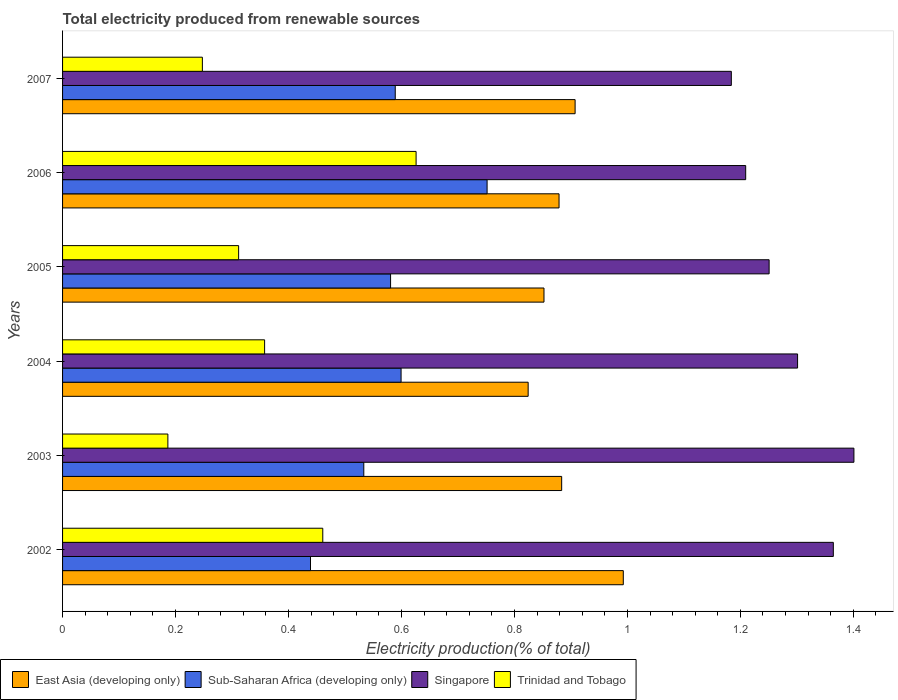How many groups of bars are there?
Your response must be concise. 6. Are the number of bars on each tick of the Y-axis equal?
Your answer should be very brief. Yes. How many bars are there on the 5th tick from the top?
Provide a succinct answer. 4. How many bars are there on the 2nd tick from the bottom?
Your answer should be compact. 4. What is the label of the 5th group of bars from the top?
Ensure brevity in your answer.  2003. What is the total electricity produced in Trinidad and Tobago in 2003?
Provide a succinct answer. 0.19. Across all years, what is the maximum total electricity produced in Trinidad and Tobago?
Your response must be concise. 0.63. Across all years, what is the minimum total electricity produced in East Asia (developing only)?
Ensure brevity in your answer.  0.82. In which year was the total electricity produced in East Asia (developing only) maximum?
Your answer should be very brief. 2002. What is the total total electricity produced in Trinidad and Tobago in the graph?
Offer a terse response. 2.19. What is the difference between the total electricity produced in Trinidad and Tobago in 2002 and that in 2005?
Your response must be concise. 0.15. What is the difference between the total electricity produced in Sub-Saharan Africa (developing only) in 2006 and the total electricity produced in East Asia (developing only) in 2003?
Your answer should be very brief. -0.13. What is the average total electricity produced in Sub-Saharan Africa (developing only) per year?
Offer a terse response. 0.58. In the year 2002, what is the difference between the total electricity produced in Trinidad and Tobago and total electricity produced in Sub-Saharan Africa (developing only)?
Offer a very short reply. 0.02. In how many years, is the total electricity produced in East Asia (developing only) greater than 0.24000000000000002 %?
Make the answer very short. 6. What is the ratio of the total electricity produced in Singapore in 2002 to that in 2004?
Offer a very short reply. 1.05. Is the total electricity produced in Sub-Saharan Africa (developing only) in 2002 less than that in 2007?
Offer a terse response. Yes. Is the difference between the total electricity produced in Trinidad and Tobago in 2003 and 2006 greater than the difference between the total electricity produced in Sub-Saharan Africa (developing only) in 2003 and 2006?
Your response must be concise. No. What is the difference between the highest and the second highest total electricity produced in Sub-Saharan Africa (developing only)?
Make the answer very short. 0.15. What is the difference between the highest and the lowest total electricity produced in Singapore?
Make the answer very short. 0.22. In how many years, is the total electricity produced in Sub-Saharan Africa (developing only) greater than the average total electricity produced in Sub-Saharan Africa (developing only) taken over all years?
Offer a terse response. 3. Is the sum of the total electricity produced in Singapore in 2002 and 2005 greater than the maximum total electricity produced in East Asia (developing only) across all years?
Ensure brevity in your answer.  Yes. Is it the case that in every year, the sum of the total electricity produced in Singapore and total electricity produced in Trinidad and Tobago is greater than the sum of total electricity produced in East Asia (developing only) and total electricity produced in Sub-Saharan Africa (developing only)?
Your answer should be compact. Yes. What does the 4th bar from the top in 2004 represents?
Give a very brief answer. East Asia (developing only). What does the 3rd bar from the bottom in 2003 represents?
Provide a succinct answer. Singapore. Are the values on the major ticks of X-axis written in scientific E-notation?
Give a very brief answer. No. Where does the legend appear in the graph?
Offer a very short reply. Bottom left. What is the title of the graph?
Your answer should be compact. Total electricity produced from renewable sources. What is the label or title of the X-axis?
Your answer should be very brief. Electricity production(% of total). What is the label or title of the Y-axis?
Provide a succinct answer. Years. What is the Electricity production(% of total) of East Asia (developing only) in 2002?
Give a very brief answer. 0.99. What is the Electricity production(% of total) in Sub-Saharan Africa (developing only) in 2002?
Offer a very short reply. 0.44. What is the Electricity production(% of total) in Singapore in 2002?
Offer a very short reply. 1.36. What is the Electricity production(% of total) of Trinidad and Tobago in 2002?
Your answer should be compact. 0.46. What is the Electricity production(% of total) of East Asia (developing only) in 2003?
Ensure brevity in your answer.  0.88. What is the Electricity production(% of total) in Sub-Saharan Africa (developing only) in 2003?
Offer a terse response. 0.53. What is the Electricity production(% of total) of Singapore in 2003?
Your answer should be very brief. 1.4. What is the Electricity production(% of total) in Trinidad and Tobago in 2003?
Offer a terse response. 0.19. What is the Electricity production(% of total) in East Asia (developing only) in 2004?
Your response must be concise. 0.82. What is the Electricity production(% of total) in Sub-Saharan Africa (developing only) in 2004?
Your answer should be compact. 0.6. What is the Electricity production(% of total) in Singapore in 2004?
Keep it short and to the point. 1.3. What is the Electricity production(% of total) of Trinidad and Tobago in 2004?
Your answer should be compact. 0.36. What is the Electricity production(% of total) in East Asia (developing only) in 2005?
Provide a short and direct response. 0.85. What is the Electricity production(% of total) in Sub-Saharan Africa (developing only) in 2005?
Keep it short and to the point. 0.58. What is the Electricity production(% of total) of Singapore in 2005?
Ensure brevity in your answer.  1.25. What is the Electricity production(% of total) of Trinidad and Tobago in 2005?
Provide a succinct answer. 0.31. What is the Electricity production(% of total) of East Asia (developing only) in 2006?
Your response must be concise. 0.88. What is the Electricity production(% of total) of Sub-Saharan Africa (developing only) in 2006?
Your answer should be compact. 0.75. What is the Electricity production(% of total) in Singapore in 2006?
Offer a terse response. 1.21. What is the Electricity production(% of total) of Trinidad and Tobago in 2006?
Offer a terse response. 0.63. What is the Electricity production(% of total) in East Asia (developing only) in 2007?
Give a very brief answer. 0.91. What is the Electricity production(% of total) in Sub-Saharan Africa (developing only) in 2007?
Your answer should be very brief. 0.59. What is the Electricity production(% of total) of Singapore in 2007?
Ensure brevity in your answer.  1.18. What is the Electricity production(% of total) of Trinidad and Tobago in 2007?
Your answer should be compact. 0.25. Across all years, what is the maximum Electricity production(% of total) in East Asia (developing only)?
Keep it short and to the point. 0.99. Across all years, what is the maximum Electricity production(% of total) of Sub-Saharan Africa (developing only)?
Give a very brief answer. 0.75. Across all years, what is the maximum Electricity production(% of total) of Singapore?
Provide a short and direct response. 1.4. Across all years, what is the maximum Electricity production(% of total) of Trinidad and Tobago?
Ensure brevity in your answer.  0.63. Across all years, what is the minimum Electricity production(% of total) in East Asia (developing only)?
Provide a succinct answer. 0.82. Across all years, what is the minimum Electricity production(% of total) of Sub-Saharan Africa (developing only)?
Offer a very short reply. 0.44. Across all years, what is the minimum Electricity production(% of total) in Singapore?
Provide a short and direct response. 1.18. Across all years, what is the minimum Electricity production(% of total) in Trinidad and Tobago?
Your response must be concise. 0.19. What is the total Electricity production(% of total) in East Asia (developing only) in the graph?
Provide a short and direct response. 5.34. What is the total Electricity production(% of total) of Sub-Saharan Africa (developing only) in the graph?
Provide a short and direct response. 3.49. What is the total Electricity production(% of total) of Singapore in the graph?
Your response must be concise. 7.71. What is the total Electricity production(% of total) in Trinidad and Tobago in the graph?
Offer a terse response. 2.19. What is the difference between the Electricity production(% of total) in East Asia (developing only) in 2002 and that in 2003?
Keep it short and to the point. 0.11. What is the difference between the Electricity production(% of total) in Sub-Saharan Africa (developing only) in 2002 and that in 2003?
Your answer should be compact. -0.09. What is the difference between the Electricity production(% of total) of Singapore in 2002 and that in 2003?
Ensure brevity in your answer.  -0.04. What is the difference between the Electricity production(% of total) in Trinidad and Tobago in 2002 and that in 2003?
Offer a very short reply. 0.27. What is the difference between the Electricity production(% of total) in East Asia (developing only) in 2002 and that in 2004?
Ensure brevity in your answer.  0.17. What is the difference between the Electricity production(% of total) of Sub-Saharan Africa (developing only) in 2002 and that in 2004?
Your answer should be very brief. -0.16. What is the difference between the Electricity production(% of total) in Singapore in 2002 and that in 2004?
Your response must be concise. 0.06. What is the difference between the Electricity production(% of total) of Trinidad and Tobago in 2002 and that in 2004?
Your response must be concise. 0.1. What is the difference between the Electricity production(% of total) in East Asia (developing only) in 2002 and that in 2005?
Offer a very short reply. 0.14. What is the difference between the Electricity production(% of total) in Sub-Saharan Africa (developing only) in 2002 and that in 2005?
Your answer should be very brief. -0.14. What is the difference between the Electricity production(% of total) in Singapore in 2002 and that in 2005?
Provide a short and direct response. 0.11. What is the difference between the Electricity production(% of total) of Trinidad and Tobago in 2002 and that in 2005?
Offer a very short reply. 0.15. What is the difference between the Electricity production(% of total) of East Asia (developing only) in 2002 and that in 2006?
Give a very brief answer. 0.11. What is the difference between the Electricity production(% of total) in Sub-Saharan Africa (developing only) in 2002 and that in 2006?
Provide a succinct answer. -0.31. What is the difference between the Electricity production(% of total) of Singapore in 2002 and that in 2006?
Make the answer very short. 0.16. What is the difference between the Electricity production(% of total) in Trinidad and Tobago in 2002 and that in 2006?
Your answer should be compact. -0.17. What is the difference between the Electricity production(% of total) of East Asia (developing only) in 2002 and that in 2007?
Your answer should be very brief. 0.09. What is the difference between the Electricity production(% of total) in Singapore in 2002 and that in 2007?
Provide a short and direct response. 0.18. What is the difference between the Electricity production(% of total) in Trinidad and Tobago in 2002 and that in 2007?
Provide a succinct answer. 0.21. What is the difference between the Electricity production(% of total) of East Asia (developing only) in 2003 and that in 2004?
Ensure brevity in your answer.  0.06. What is the difference between the Electricity production(% of total) in Sub-Saharan Africa (developing only) in 2003 and that in 2004?
Offer a very short reply. -0.07. What is the difference between the Electricity production(% of total) in Singapore in 2003 and that in 2004?
Make the answer very short. 0.1. What is the difference between the Electricity production(% of total) in Trinidad and Tobago in 2003 and that in 2004?
Your answer should be very brief. -0.17. What is the difference between the Electricity production(% of total) of East Asia (developing only) in 2003 and that in 2005?
Your answer should be compact. 0.03. What is the difference between the Electricity production(% of total) in Sub-Saharan Africa (developing only) in 2003 and that in 2005?
Your response must be concise. -0.05. What is the difference between the Electricity production(% of total) of Singapore in 2003 and that in 2005?
Offer a very short reply. 0.15. What is the difference between the Electricity production(% of total) in Trinidad and Tobago in 2003 and that in 2005?
Make the answer very short. -0.13. What is the difference between the Electricity production(% of total) of East Asia (developing only) in 2003 and that in 2006?
Your answer should be compact. 0. What is the difference between the Electricity production(% of total) in Sub-Saharan Africa (developing only) in 2003 and that in 2006?
Provide a succinct answer. -0.22. What is the difference between the Electricity production(% of total) in Singapore in 2003 and that in 2006?
Offer a very short reply. 0.19. What is the difference between the Electricity production(% of total) in Trinidad and Tobago in 2003 and that in 2006?
Keep it short and to the point. -0.44. What is the difference between the Electricity production(% of total) of East Asia (developing only) in 2003 and that in 2007?
Your answer should be compact. -0.02. What is the difference between the Electricity production(% of total) in Sub-Saharan Africa (developing only) in 2003 and that in 2007?
Give a very brief answer. -0.06. What is the difference between the Electricity production(% of total) of Singapore in 2003 and that in 2007?
Provide a succinct answer. 0.22. What is the difference between the Electricity production(% of total) in Trinidad and Tobago in 2003 and that in 2007?
Your answer should be very brief. -0.06. What is the difference between the Electricity production(% of total) in East Asia (developing only) in 2004 and that in 2005?
Offer a very short reply. -0.03. What is the difference between the Electricity production(% of total) of Sub-Saharan Africa (developing only) in 2004 and that in 2005?
Make the answer very short. 0.02. What is the difference between the Electricity production(% of total) of Singapore in 2004 and that in 2005?
Your response must be concise. 0.05. What is the difference between the Electricity production(% of total) in Trinidad and Tobago in 2004 and that in 2005?
Make the answer very short. 0.05. What is the difference between the Electricity production(% of total) in East Asia (developing only) in 2004 and that in 2006?
Provide a short and direct response. -0.05. What is the difference between the Electricity production(% of total) of Sub-Saharan Africa (developing only) in 2004 and that in 2006?
Ensure brevity in your answer.  -0.15. What is the difference between the Electricity production(% of total) in Singapore in 2004 and that in 2006?
Give a very brief answer. 0.09. What is the difference between the Electricity production(% of total) in Trinidad and Tobago in 2004 and that in 2006?
Provide a succinct answer. -0.27. What is the difference between the Electricity production(% of total) of East Asia (developing only) in 2004 and that in 2007?
Your answer should be compact. -0.08. What is the difference between the Electricity production(% of total) in Sub-Saharan Africa (developing only) in 2004 and that in 2007?
Offer a terse response. 0.01. What is the difference between the Electricity production(% of total) of Singapore in 2004 and that in 2007?
Give a very brief answer. 0.12. What is the difference between the Electricity production(% of total) of Trinidad and Tobago in 2004 and that in 2007?
Make the answer very short. 0.11. What is the difference between the Electricity production(% of total) of East Asia (developing only) in 2005 and that in 2006?
Ensure brevity in your answer.  -0.03. What is the difference between the Electricity production(% of total) in Sub-Saharan Africa (developing only) in 2005 and that in 2006?
Your response must be concise. -0.17. What is the difference between the Electricity production(% of total) in Singapore in 2005 and that in 2006?
Your answer should be compact. 0.04. What is the difference between the Electricity production(% of total) in Trinidad and Tobago in 2005 and that in 2006?
Offer a very short reply. -0.31. What is the difference between the Electricity production(% of total) of East Asia (developing only) in 2005 and that in 2007?
Offer a terse response. -0.06. What is the difference between the Electricity production(% of total) in Sub-Saharan Africa (developing only) in 2005 and that in 2007?
Keep it short and to the point. -0.01. What is the difference between the Electricity production(% of total) of Singapore in 2005 and that in 2007?
Offer a terse response. 0.07. What is the difference between the Electricity production(% of total) in Trinidad and Tobago in 2005 and that in 2007?
Offer a terse response. 0.06. What is the difference between the Electricity production(% of total) of East Asia (developing only) in 2006 and that in 2007?
Your answer should be compact. -0.03. What is the difference between the Electricity production(% of total) in Sub-Saharan Africa (developing only) in 2006 and that in 2007?
Ensure brevity in your answer.  0.16. What is the difference between the Electricity production(% of total) of Singapore in 2006 and that in 2007?
Ensure brevity in your answer.  0.03. What is the difference between the Electricity production(% of total) of Trinidad and Tobago in 2006 and that in 2007?
Provide a succinct answer. 0.38. What is the difference between the Electricity production(% of total) in East Asia (developing only) in 2002 and the Electricity production(% of total) in Sub-Saharan Africa (developing only) in 2003?
Ensure brevity in your answer.  0.46. What is the difference between the Electricity production(% of total) in East Asia (developing only) in 2002 and the Electricity production(% of total) in Singapore in 2003?
Your answer should be compact. -0.41. What is the difference between the Electricity production(% of total) of East Asia (developing only) in 2002 and the Electricity production(% of total) of Trinidad and Tobago in 2003?
Ensure brevity in your answer.  0.81. What is the difference between the Electricity production(% of total) of Sub-Saharan Africa (developing only) in 2002 and the Electricity production(% of total) of Singapore in 2003?
Your answer should be compact. -0.96. What is the difference between the Electricity production(% of total) in Sub-Saharan Africa (developing only) in 2002 and the Electricity production(% of total) in Trinidad and Tobago in 2003?
Your response must be concise. 0.25. What is the difference between the Electricity production(% of total) in Singapore in 2002 and the Electricity production(% of total) in Trinidad and Tobago in 2003?
Make the answer very short. 1.18. What is the difference between the Electricity production(% of total) in East Asia (developing only) in 2002 and the Electricity production(% of total) in Sub-Saharan Africa (developing only) in 2004?
Your answer should be compact. 0.39. What is the difference between the Electricity production(% of total) in East Asia (developing only) in 2002 and the Electricity production(% of total) in Singapore in 2004?
Provide a short and direct response. -0.31. What is the difference between the Electricity production(% of total) of East Asia (developing only) in 2002 and the Electricity production(% of total) of Trinidad and Tobago in 2004?
Keep it short and to the point. 0.64. What is the difference between the Electricity production(% of total) of Sub-Saharan Africa (developing only) in 2002 and the Electricity production(% of total) of Singapore in 2004?
Make the answer very short. -0.86. What is the difference between the Electricity production(% of total) of Sub-Saharan Africa (developing only) in 2002 and the Electricity production(% of total) of Trinidad and Tobago in 2004?
Offer a very short reply. 0.08. What is the difference between the Electricity production(% of total) in Singapore in 2002 and the Electricity production(% of total) in Trinidad and Tobago in 2004?
Make the answer very short. 1.01. What is the difference between the Electricity production(% of total) of East Asia (developing only) in 2002 and the Electricity production(% of total) of Sub-Saharan Africa (developing only) in 2005?
Give a very brief answer. 0.41. What is the difference between the Electricity production(% of total) of East Asia (developing only) in 2002 and the Electricity production(% of total) of Singapore in 2005?
Provide a short and direct response. -0.26. What is the difference between the Electricity production(% of total) in East Asia (developing only) in 2002 and the Electricity production(% of total) in Trinidad and Tobago in 2005?
Your response must be concise. 0.68. What is the difference between the Electricity production(% of total) in Sub-Saharan Africa (developing only) in 2002 and the Electricity production(% of total) in Singapore in 2005?
Ensure brevity in your answer.  -0.81. What is the difference between the Electricity production(% of total) of Sub-Saharan Africa (developing only) in 2002 and the Electricity production(% of total) of Trinidad and Tobago in 2005?
Your response must be concise. 0.13. What is the difference between the Electricity production(% of total) of Singapore in 2002 and the Electricity production(% of total) of Trinidad and Tobago in 2005?
Your answer should be compact. 1.05. What is the difference between the Electricity production(% of total) in East Asia (developing only) in 2002 and the Electricity production(% of total) in Sub-Saharan Africa (developing only) in 2006?
Provide a succinct answer. 0.24. What is the difference between the Electricity production(% of total) of East Asia (developing only) in 2002 and the Electricity production(% of total) of Singapore in 2006?
Keep it short and to the point. -0.22. What is the difference between the Electricity production(% of total) in East Asia (developing only) in 2002 and the Electricity production(% of total) in Trinidad and Tobago in 2006?
Keep it short and to the point. 0.37. What is the difference between the Electricity production(% of total) in Sub-Saharan Africa (developing only) in 2002 and the Electricity production(% of total) in Singapore in 2006?
Provide a succinct answer. -0.77. What is the difference between the Electricity production(% of total) of Sub-Saharan Africa (developing only) in 2002 and the Electricity production(% of total) of Trinidad and Tobago in 2006?
Keep it short and to the point. -0.19. What is the difference between the Electricity production(% of total) of Singapore in 2002 and the Electricity production(% of total) of Trinidad and Tobago in 2006?
Your response must be concise. 0.74. What is the difference between the Electricity production(% of total) in East Asia (developing only) in 2002 and the Electricity production(% of total) in Sub-Saharan Africa (developing only) in 2007?
Your answer should be compact. 0.4. What is the difference between the Electricity production(% of total) in East Asia (developing only) in 2002 and the Electricity production(% of total) in Singapore in 2007?
Keep it short and to the point. -0.19. What is the difference between the Electricity production(% of total) of East Asia (developing only) in 2002 and the Electricity production(% of total) of Trinidad and Tobago in 2007?
Give a very brief answer. 0.75. What is the difference between the Electricity production(% of total) in Sub-Saharan Africa (developing only) in 2002 and the Electricity production(% of total) in Singapore in 2007?
Offer a very short reply. -0.74. What is the difference between the Electricity production(% of total) in Sub-Saharan Africa (developing only) in 2002 and the Electricity production(% of total) in Trinidad and Tobago in 2007?
Keep it short and to the point. 0.19. What is the difference between the Electricity production(% of total) of Singapore in 2002 and the Electricity production(% of total) of Trinidad and Tobago in 2007?
Give a very brief answer. 1.12. What is the difference between the Electricity production(% of total) in East Asia (developing only) in 2003 and the Electricity production(% of total) in Sub-Saharan Africa (developing only) in 2004?
Offer a terse response. 0.28. What is the difference between the Electricity production(% of total) of East Asia (developing only) in 2003 and the Electricity production(% of total) of Singapore in 2004?
Ensure brevity in your answer.  -0.42. What is the difference between the Electricity production(% of total) of East Asia (developing only) in 2003 and the Electricity production(% of total) of Trinidad and Tobago in 2004?
Your response must be concise. 0.53. What is the difference between the Electricity production(% of total) in Sub-Saharan Africa (developing only) in 2003 and the Electricity production(% of total) in Singapore in 2004?
Ensure brevity in your answer.  -0.77. What is the difference between the Electricity production(% of total) of Sub-Saharan Africa (developing only) in 2003 and the Electricity production(% of total) of Trinidad and Tobago in 2004?
Offer a terse response. 0.18. What is the difference between the Electricity production(% of total) in Singapore in 2003 and the Electricity production(% of total) in Trinidad and Tobago in 2004?
Your answer should be compact. 1.04. What is the difference between the Electricity production(% of total) in East Asia (developing only) in 2003 and the Electricity production(% of total) in Sub-Saharan Africa (developing only) in 2005?
Make the answer very short. 0.3. What is the difference between the Electricity production(% of total) in East Asia (developing only) in 2003 and the Electricity production(% of total) in Singapore in 2005?
Ensure brevity in your answer.  -0.37. What is the difference between the Electricity production(% of total) of East Asia (developing only) in 2003 and the Electricity production(% of total) of Trinidad and Tobago in 2005?
Offer a very short reply. 0.57. What is the difference between the Electricity production(% of total) in Sub-Saharan Africa (developing only) in 2003 and the Electricity production(% of total) in Singapore in 2005?
Your answer should be very brief. -0.72. What is the difference between the Electricity production(% of total) of Sub-Saharan Africa (developing only) in 2003 and the Electricity production(% of total) of Trinidad and Tobago in 2005?
Make the answer very short. 0.22. What is the difference between the Electricity production(% of total) in Singapore in 2003 and the Electricity production(% of total) in Trinidad and Tobago in 2005?
Keep it short and to the point. 1.09. What is the difference between the Electricity production(% of total) in East Asia (developing only) in 2003 and the Electricity production(% of total) in Sub-Saharan Africa (developing only) in 2006?
Make the answer very short. 0.13. What is the difference between the Electricity production(% of total) in East Asia (developing only) in 2003 and the Electricity production(% of total) in Singapore in 2006?
Your response must be concise. -0.33. What is the difference between the Electricity production(% of total) of East Asia (developing only) in 2003 and the Electricity production(% of total) of Trinidad and Tobago in 2006?
Make the answer very short. 0.26. What is the difference between the Electricity production(% of total) in Sub-Saharan Africa (developing only) in 2003 and the Electricity production(% of total) in Singapore in 2006?
Give a very brief answer. -0.68. What is the difference between the Electricity production(% of total) of Sub-Saharan Africa (developing only) in 2003 and the Electricity production(% of total) of Trinidad and Tobago in 2006?
Keep it short and to the point. -0.09. What is the difference between the Electricity production(% of total) in Singapore in 2003 and the Electricity production(% of total) in Trinidad and Tobago in 2006?
Keep it short and to the point. 0.78. What is the difference between the Electricity production(% of total) of East Asia (developing only) in 2003 and the Electricity production(% of total) of Sub-Saharan Africa (developing only) in 2007?
Offer a terse response. 0.29. What is the difference between the Electricity production(% of total) in East Asia (developing only) in 2003 and the Electricity production(% of total) in Singapore in 2007?
Keep it short and to the point. -0.3. What is the difference between the Electricity production(% of total) in East Asia (developing only) in 2003 and the Electricity production(% of total) in Trinidad and Tobago in 2007?
Provide a succinct answer. 0.64. What is the difference between the Electricity production(% of total) of Sub-Saharan Africa (developing only) in 2003 and the Electricity production(% of total) of Singapore in 2007?
Your response must be concise. -0.65. What is the difference between the Electricity production(% of total) in Sub-Saharan Africa (developing only) in 2003 and the Electricity production(% of total) in Trinidad and Tobago in 2007?
Offer a very short reply. 0.29. What is the difference between the Electricity production(% of total) of Singapore in 2003 and the Electricity production(% of total) of Trinidad and Tobago in 2007?
Your answer should be very brief. 1.15. What is the difference between the Electricity production(% of total) of East Asia (developing only) in 2004 and the Electricity production(% of total) of Sub-Saharan Africa (developing only) in 2005?
Make the answer very short. 0.24. What is the difference between the Electricity production(% of total) of East Asia (developing only) in 2004 and the Electricity production(% of total) of Singapore in 2005?
Your answer should be compact. -0.43. What is the difference between the Electricity production(% of total) of East Asia (developing only) in 2004 and the Electricity production(% of total) of Trinidad and Tobago in 2005?
Keep it short and to the point. 0.51. What is the difference between the Electricity production(% of total) of Sub-Saharan Africa (developing only) in 2004 and the Electricity production(% of total) of Singapore in 2005?
Provide a succinct answer. -0.65. What is the difference between the Electricity production(% of total) in Sub-Saharan Africa (developing only) in 2004 and the Electricity production(% of total) in Trinidad and Tobago in 2005?
Your answer should be compact. 0.29. What is the difference between the Electricity production(% of total) of Singapore in 2004 and the Electricity production(% of total) of Trinidad and Tobago in 2005?
Provide a succinct answer. 0.99. What is the difference between the Electricity production(% of total) of East Asia (developing only) in 2004 and the Electricity production(% of total) of Sub-Saharan Africa (developing only) in 2006?
Give a very brief answer. 0.07. What is the difference between the Electricity production(% of total) of East Asia (developing only) in 2004 and the Electricity production(% of total) of Singapore in 2006?
Give a very brief answer. -0.39. What is the difference between the Electricity production(% of total) in East Asia (developing only) in 2004 and the Electricity production(% of total) in Trinidad and Tobago in 2006?
Your answer should be very brief. 0.2. What is the difference between the Electricity production(% of total) in Sub-Saharan Africa (developing only) in 2004 and the Electricity production(% of total) in Singapore in 2006?
Offer a terse response. -0.61. What is the difference between the Electricity production(% of total) in Sub-Saharan Africa (developing only) in 2004 and the Electricity production(% of total) in Trinidad and Tobago in 2006?
Your response must be concise. -0.03. What is the difference between the Electricity production(% of total) of Singapore in 2004 and the Electricity production(% of total) of Trinidad and Tobago in 2006?
Provide a succinct answer. 0.68. What is the difference between the Electricity production(% of total) of East Asia (developing only) in 2004 and the Electricity production(% of total) of Sub-Saharan Africa (developing only) in 2007?
Offer a terse response. 0.24. What is the difference between the Electricity production(% of total) of East Asia (developing only) in 2004 and the Electricity production(% of total) of Singapore in 2007?
Keep it short and to the point. -0.36. What is the difference between the Electricity production(% of total) of East Asia (developing only) in 2004 and the Electricity production(% of total) of Trinidad and Tobago in 2007?
Your answer should be very brief. 0.58. What is the difference between the Electricity production(% of total) of Sub-Saharan Africa (developing only) in 2004 and the Electricity production(% of total) of Singapore in 2007?
Keep it short and to the point. -0.58. What is the difference between the Electricity production(% of total) in Sub-Saharan Africa (developing only) in 2004 and the Electricity production(% of total) in Trinidad and Tobago in 2007?
Keep it short and to the point. 0.35. What is the difference between the Electricity production(% of total) of Singapore in 2004 and the Electricity production(% of total) of Trinidad and Tobago in 2007?
Your answer should be compact. 1.05. What is the difference between the Electricity production(% of total) of East Asia (developing only) in 2005 and the Electricity production(% of total) of Sub-Saharan Africa (developing only) in 2006?
Offer a terse response. 0.1. What is the difference between the Electricity production(% of total) of East Asia (developing only) in 2005 and the Electricity production(% of total) of Singapore in 2006?
Your answer should be very brief. -0.36. What is the difference between the Electricity production(% of total) in East Asia (developing only) in 2005 and the Electricity production(% of total) in Trinidad and Tobago in 2006?
Provide a short and direct response. 0.23. What is the difference between the Electricity production(% of total) of Sub-Saharan Africa (developing only) in 2005 and the Electricity production(% of total) of Singapore in 2006?
Keep it short and to the point. -0.63. What is the difference between the Electricity production(% of total) of Sub-Saharan Africa (developing only) in 2005 and the Electricity production(% of total) of Trinidad and Tobago in 2006?
Your response must be concise. -0.05. What is the difference between the Electricity production(% of total) of Singapore in 2005 and the Electricity production(% of total) of Trinidad and Tobago in 2006?
Provide a short and direct response. 0.62. What is the difference between the Electricity production(% of total) in East Asia (developing only) in 2005 and the Electricity production(% of total) in Sub-Saharan Africa (developing only) in 2007?
Make the answer very short. 0.26. What is the difference between the Electricity production(% of total) in East Asia (developing only) in 2005 and the Electricity production(% of total) in Singapore in 2007?
Your response must be concise. -0.33. What is the difference between the Electricity production(% of total) of East Asia (developing only) in 2005 and the Electricity production(% of total) of Trinidad and Tobago in 2007?
Offer a very short reply. 0.6. What is the difference between the Electricity production(% of total) of Sub-Saharan Africa (developing only) in 2005 and the Electricity production(% of total) of Singapore in 2007?
Provide a short and direct response. -0.6. What is the difference between the Electricity production(% of total) of Sub-Saharan Africa (developing only) in 2005 and the Electricity production(% of total) of Trinidad and Tobago in 2007?
Give a very brief answer. 0.33. What is the difference between the Electricity production(% of total) in East Asia (developing only) in 2006 and the Electricity production(% of total) in Sub-Saharan Africa (developing only) in 2007?
Provide a succinct answer. 0.29. What is the difference between the Electricity production(% of total) of East Asia (developing only) in 2006 and the Electricity production(% of total) of Singapore in 2007?
Keep it short and to the point. -0.3. What is the difference between the Electricity production(% of total) of East Asia (developing only) in 2006 and the Electricity production(% of total) of Trinidad and Tobago in 2007?
Your response must be concise. 0.63. What is the difference between the Electricity production(% of total) in Sub-Saharan Africa (developing only) in 2006 and the Electricity production(% of total) in Singapore in 2007?
Offer a terse response. -0.43. What is the difference between the Electricity production(% of total) in Sub-Saharan Africa (developing only) in 2006 and the Electricity production(% of total) in Trinidad and Tobago in 2007?
Make the answer very short. 0.5. What is the difference between the Electricity production(% of total) in Singapore in 2006 and the Electricity production(% of total) in Trinidad and Tobago in 2007?
Keep it short and to the point. 0.96. What is the average Electricity production(% of total) of East Asia (developing only) per year?
Provide a short and direct response. 0.89. What is the average Electricity production(% of total) of Sub-Saharan Africa (developing only) per year?
Provide a short and direct response. 0.58. What is the average Electricity production(% of total) in Singapore per year?
Keep it short and to the point. 1.29. What is the average Electricity production(% of total) in Trinidad and Tobago per year?
Make the answer very short. 0.36. In the year 2002, what is the difference between the Electricity production(% of total) of East Asia (developing only) and Electricity production(% of total) of Sub-Saharan Africa (developing only)?
Ensure brevity in your answer.  0.55. In the year 2002, what is the difference between the Electricity production(% of total) of East Asia (developing only) and Electricity production(% of total) of Singapore?
Keep it short and to the point. -0.37. In the year 2002, what is the difference between the Electricity production(% of total) in East Asia (developing only) and Electricity production(% of total) in Trinidad and Tobago?
Ensure brevity in your answer.  0.53. In the year 2002, what is the difference between the Electricity production(% of total) in Sub-Saharan Africa (developing only) and Electricity production(% of total) in Singapore?
Offer a very short reply. -0.93. In the year 2002, what is the difference between the Electricity production(% of total) in Sub-Saharan Africa (developing only) and Electricity production(% of total) in Trinidad and Tobago?
Your answer should be compact. -0.02. In the year 2002, what is the difference between the Electricity production(% of total) of Singapore and Electricity production(% of total) of Trinidad and Tobago?
Keep it short and to the point. 0.9. In the year 2003, what is the difference between the Electricity production(% of total) in East Asia (developing only) and Electricity production(% of total) in Sub-Saharan Africa (developing only)?
Give a very brief answer. 0.35. In the year 2003, what is the difference between the Electricity production(% of total) of East Asia (developing only) and Electricity production(% of total) of Singapore?
Your answer should be very brief. -0.52. In the year 2003, what is the difference between the Electricity production(% of total) in East Asia (developing only) and Electricity production(% of total) in Trinidad and Tobago?
Provide a succinct answer. 0.7. In the year 2003, what is the difference between the Electricity production(% of total) in Sub-Saharan Africa (developing only) and Electricity production(% of total) in Singapore?
Your response must be concise. -0.87. In the year 2003, what is the difference between the Electricity production(% of total) of Sub-Saharan Africa (developing only) and Electricity production(% of total) of Trinidad and Tobago?
Make the answer very short. 0.35. In the year 2003, what is the difference between the Electricity production(% of total) in Singapore and Electricity production(% of total) in Trinidad and Tobago?
Ensure brevity in your answer.  1.21. In the year 2004, what is the difference between the Electricity production(% of total) in East Asia (developing only) and Electricity production(% of total) in Sub-Saharan Africa (developing only)?
Make the answer very short. 0.23. In the year 2004, what is the difference between the Electricity production(% of total) of East Asia (developing only) and Electricity production(% of total) of Singapore?
Keep it short and to the point. -0.48. In the year 2004, what is the difference between the Electricity production(% of total) of East Asia (developing only) and Electricity production(% of total) of Trinidad and Tobago?
Your response must be concise. 0.47. In the year 2004, what is the difference between the Electricity production(% of total) of Sub-Saharan Africa (developing only) and Electricity production(% of total) of Singapore?
Offer a very short reply. -0.7. In the year 2004, what is the difference between the Electricity production(% of total) in Sub-Saharan Africa (developing only) and Electricity production(% of total) in Trinidad and Tobago?
Provide a succinct answer. 0.24. In the year 2004, what is the difference between the Electricity production(% of total) in Singapore and Electricity production(% of total) in Trinidad and Tobago?
Provide a succinct answer. 0.94. In the year 2005, what is the difference between the Electricity production(% of total) in East Asia (developing only) and Electricity production(% of total) in Sub-Saharan Africa (developing only)?
Provide a succinct answer. 0.27. In the year 2005, what is the difference between the Electricity production(% of total) of East Asia (developing only) and Electricity production(% of total) of Singapore?
Your answer should be very brief. -0.4. In the year 2005, what is the difference between the Electricity production(% of total) in East Asia (developing only) and Electricity production(% of total) in Trinidad and Tobago?
Your answer should be very brief. 0.54. In the year 2005, what is the difference between the Electricity production(% of total) in Sub-Saharan Africa (developing only) and Electricity production(% of total) in Singapore?
Provide a short and direct response. -0.67. In the year 2005, what is the difference between the Electricity production(% of total) in Sub-Saharan Africa (developing only) and Electricity production(% of total) in Trinidad and Tobago?
Your answer should be very brief. 0.27. In the year 2005, what is the difference between the Electricity production(% of total) of Singapore and Electricity production(% of total) of Trinidad and Tobago?
Offer a terse response. 0.94. In the year 2006, what is the difference between the Electricity production(% of total) of East Asia (developing only) and Electricity production(% of total) of Sub-Saharan Africa (developing only)?
Provide a succinct answer. 0.13. In the year 2006, what is the difference between the Electricity production(% of total) of East Asia (developing only) and Electricity production(% of total) of Singapore?
Provide a succinct answer. -0.33. In the year 2006, what is the difference between the Electricity production(% of total) of East Asia (developing only) and Electricity production(% of total) of Trinidad and Tobago?
Your answer should be very brief. 0.25. In the year 2006, what is the difference between the Electricity production(% of total) in Sub-Saharan Africa (developing only) and Electricity production(% of total) in Singapore?
Give a very brief answer. -0.46. In the year 2006, what is the difference between the Electricity production(% of total) of Sub-Saharan Africa (developing only) and Electricity production(% of total) of Trinidad and Tobago?
Offer a terse response. 0.13. In the year 2006, what is the difference between the Electricity production(% of total) of Singapore and Electricity production(% of total) of Trinidad and Tobago?
Keep it short and to the point. 0.58. In the year 2007, what is the difference between the Electricity production(% of total) of East Asia (developing only) and Electricity production(% of total) of Sub-Saharan Africa (developing only)?
Your answer should be compact. 0.32. In the year 2007, what is the difference between the Electricity production(% of total) in East Asia (developing only) and Electricity production(% of total) in Singapore?
Provide a short and direct response. -0.28. In the year 2007, what is the difference between the Electricity production(% of total) in East Asia (developing only) and Electricity production(% of total) in Trinidad and Tobago?
Provide a succinct answer. 0.66. In the year 2007, what is the difference between the Electricity production(% of total) in Sub-Saharan Africa (developing only) and Electricity production(% of total) in Singapore?
Give a very brief answer. -0.59. In the year 2007, what is the difference between the Electricity production(% of total) of Sub-Saharan Africa (developing only) and Electricity production(% of total) of Trinidad and Tobago?
Offer a very short reply. 0.34. In the year 2007, what is the difference between the Electricity production(% of total) in Singapore and Electricity production(% of total) in Trinidad and Tobago?
Give a very brief answer. 0.94. What is the ratio of the Electricity production(% of total) of East Asia (developing only) in 2002 to that in 2003?
Give a very brief answer. 1.12. What is the ratio of the Electricity production(% of total) of Sub-Saharan Africa (developing only) in 2002 to that in 2003?
Keep it short and to the point. 0.82. What is the ratio of the Electricity production(% of total) in Singapore in 2002 to that in 2003?
Provide a succinct answer. 0.97. What is the ratio of the Electricity production(% of total) in Trinidad and Tobago in 2002 to that in 2003?
Give a very brief answer. 2.47. What is the ratio of the Electricity production(% of total) of East Asia (developing only) in 2002 to that in 2004?
Provide a succinct answer. 1.2. What is the ratio of the Electricity production(% of total) of Sub-Saharan Africa (developing only) in 2002 to that in 2004?
Provide a short and direct response. 0.73. What is the ratio of the Electricity production(% of total) in Singapore in 2002 to that in 2004?
Ensure brevity in your answer.  1.05. What is the ratio of the Electricity production(% of total) in Trinidad and Tobago in 2002 to that in 2004?
Offer a very short reply. 1.29. What is the ratio of the Electricity production(% of total) of East Asia (developing only) in 2002 to that in 2005?
Your answer should be compact. 1.16. What is the ratio of the Electricity production(% of total) in Sub-Saharan Africa (developing only) in 2002 to that in 2005?
Keep it short and to the point. 0.76. What is the ratio of the Electricity production(% of total) of Trinidad and Tobago in 2002 to that in 2005?
Provide a short and direct response. 1.48. What is the ratio of the Electricity production(% of total) of East Asia (developing only) in 2002 to that in 2006?
Your answer should be very brief. 1.13. What is the ratio of the Electricity production(% of total) in Sub-Saharan Africa (developing only) in 2002 to that in 2006?
Provide a succinct answer. 0.58. What is the ratio of the Electricity production(% of total) in Singapore in 2002 to that in 2006?
Offer a terse response. 1.13. What is the ratio of the Electricity production(% of total) of Trinidad and Tobago in 2002 to that in 2006?
Offer a very short reply. 0.74. What is the ratio of the Electricity production(% of total) of East Asia (developing only) in 2002 to that in 2007?
Offer a very short reply. 1.09. What is the ratio of the Electricity production(% of total) in Sub-Saharan Africa (developing only) in 2002 to that in 2007?
Make the answer very short. 0.75. What is the ratio of the Electricity production(% of total) of Singapore in 2002 to that in 2007?
Your response must be concise. 1.15. What is the ratio of the Electricity production(% of total) in Trinidad and Tobago in 2002 to that in 2007?
Offer a terse response. 1.86. What is the ratio of the Electricity production(% of total) in East Asia (developing only) in 2003 to that in 2004?
Provide a succinct answer. 1.07. What is the ratio of the Electricity production(% of total) of Sub-Saharan Africa (developing only) in 2003 to that in 2004?
Ensure brevity in your answer.  0.89. What is the ratio of the Electricity production(% of total) in Singapore in 2003 to that in 2004?
Ensure brevity in your answer.  1.08. What is the ratio of the Electricity production(% of total) of Trinidad and Tobago in 2003 to that in 2004?
Offer a very short reply. 0.52. What is the ratio of the Electricity production(% of total) of East Asia (developing only) in 2003 to that in 2005?
Provide a short and direct response. 1.04. What is the ratio of the Electricity production(% of total) in Sub-Saharan Africa (developing only) in 2003 to that in 2005?
Offer a terse response. 0.92. What is the ratio of the Electricity production(% of total) of Singapore in 2003 to that in 2005?
Your response must be concise. 1.12. What is the ratio of the Electricity production(% of total) in Trinidad and Tobago in 2003 to that in 2005?
Provide a succinct answer. 0.6. What is the ratio of the Electricity production(% of total) in East Asia (developing only) in 2003 to that in 2006?
Your answer should be very brief. 1.01. What is the ratio of the Electricity production(% of total) of Sub-Saharan Africa (developing only) in 2003 to that in 2006?
Make the answer very short. 0.71. What is the ratio of the Electricity production(% of total) of Singapore in 2003 to that in 2006?
Keep it short and to the point. 1.16. What is the ratio of the Electricity production(% of total) of Trinidad and Tobago in 2003 to that in 2006?
Your answer should be compact. 0.3. What is the ratio of the Electricity production(% of total) of East Asia (developing only) in 2003 to that in 2007?
Make the answer very short. 0.97. What is the ratio of the Electricity production(% of total) of Sub-Saharan Africa (developing only) in 2003 to that in 2007?
Ensure brevity in your answer.  0.91. What is the ratio of the Electricity production(% of total) of Singapore in 2003 to that in 2007?
Keep it short and to the point. 1.18. What is the ratio of the Electricity production(% of total) of Trinidad and Tobago in 2003 to that in 2007?
Keep it short and to the point. 0.75. What is the ratio of the Electricity production(% of total) of East Asia (developing only) in 2004 to that in 2005?
Offer a terse response. 0.97. What is the ratio of the Electricity production(% of total) of Sub-Saharan Africa (developing only) in 2004 to that in 2005?
Your response must be concise. 1.03. What is the ratio of the Electricity production(% of total) of Singapore in 2004 to that in 2005?
Your answer should be compact. 1.04. What is the ratio of the Electricity production(% of total) of Trinidad and Tobago in 2004 to that in 2005?
Offer a very short reply. 1.15. What is the ratio of the Electricity production(% of total) of East Asia (developing only) in 2004 to that in 2006?
Provide a succinct answer. 0.94. What is the ratio of the Electricity production(% of total) in Sub-Saharan Africa (developing only) in 2004 to that in 2006?
Your answer should be compact. 0.8. What is the ratio of the Electricity production(% of total) of Singapore in 2004 to that in 2006?
Ensure brevity in your answer.  1.08. What is the ratio of the Electricity production(% of total) of Trinidad and Tobago in 2004 to that in 2006?
Give a very brief answer. 0.57. What is the ratio of the Electricity production(% of total) of East Asia (developing only) in 2004 to that in 2007?
Give a very brief answer. 0.91. What is the ratio of the Electricity production(% of total) of Sub-Saharan Africa (developing only) in 2004 to that in 2007?
Ensure brevity in your answer.  1.02. What is the ratio of the Electricity production(% of total) of Singapore in 2004 to that in 2007?
Make the answer very short. 1.1. What is the ratio of the Electricity production(% of total) in Trinidad and Tobago in 2004 to that in 2007?
Your answer should be very brief. 1.45. What is the ratio of the Electricity production(% of total) of East Asia (developing only) in 2005 to that in 2006?
Your response must be concise. 0.97. What is the ratio of the Electricity production(% of total) of Sub-Saharan Africa (developing only) in 2005 to that in 2006?
Offer a terse response. 0.77. What is the ratio of the Electricity production(% of total) of Singapore in 2005 to that in 2006?
Your answer should be very brief. 1.03. What is the ratio of the Electricity production(% of total) of Trinidad and Tobago in 2005 to that in 2006?
Ensure brevity in your answer.  0.5. What is the ratio of the Electricity production(% of total) in East Asia (developing only) in 2005 to that in 2007?
Give a very brief answer. 0.94. What is the ratio of the Electricity production(% of total) in Singapore in 2005 to that in 2007?
Keep it short and to the point. 1.06. What is the ratio of the Electricity production(% of total) in Trinidad and Tobago in 2005 to that in 2007?
Make the answer very short. 1.26. What is the ratio of the Electricity production(% of total) in East Asia (developing only) in 2006 to that in 2007?
Your response must be concise. 0.97. What is the ratio of the Electricity production(% of total) of Sub-Saharan Africa (developing only) in 2006 to that in 2007?
Your answer should be compact. 1.28. What is the ratio of the Electricity production(% of total) in Singapore in 2006 to that in 2007?
Provide a short and direct response. 1.02. What is the ratio of the Electricity production(% of total) in Trinidad and Tobago in 2006 to that in 2007?
Provide a succinct answer. 2.53. What is the difference between the highest and the second highest Electricity production(% of total) in East Asia (developing only)?
Offer a terse response. 0.09. What is the difference between the highest and the second highest Electricity production(% of total) of Sub-Saharan Africa (developing only)?
Your answer should be very brief. 0.15. What is the difference between the highest and the second highest Electricity production(% of total) in Singapore?
Your answer should be very brief. 0.04. What is the difference between the highest and the second highest Electricity production(% of total) of Trinidad and Tobago?
Provide a short and direct response. 0.17. What is the difference between the highest and the lowest Electricity production(% of total) in East Asia (developing only)?
Provide a short and direct response. 0.17. What is the difference between the highest and the lowest Electricity production(% of total) of Sub-Saharan Africa (developing only)?
Offer a terse response. 0.31. What is the difference between the highest and the lowest Electricity production(% of total) in Singapore?
Give a very brief answer. 0.22. What is the difference between the highest and the lowest Electricity production(% of total) of Trinidad and Tobago?
Offer a very short reply. 0.44. 